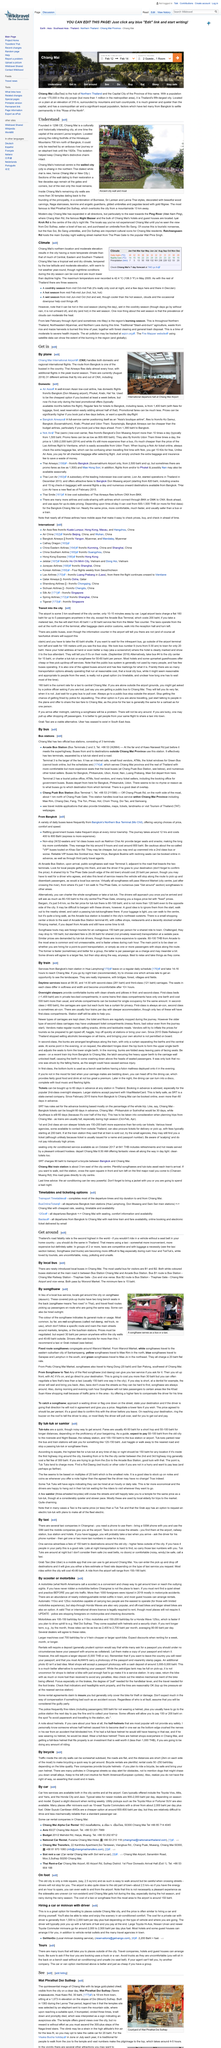Outline some significant characteristics in this image. The most useful bus lines for visitors are lines B1 and B2. It is advisable to be vigilant and aware of potential obstacles, including dogs that may pursue you in small alleys while in Chiang Mai. The distance between the airport and the old part of town is approximately 2.5 kilometers. The cost of bicycle rentals varies between 50 and 250 Thai baht per day, depending on the quality of the bike rented. The cost of a taxi or songthaew ride to the airport is approximately 150 baht, providing a convenient and affordable transportation option for travelers. 